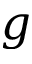<formula> <loc_0><loc_0><loc_500><loc_500>g</formula> 